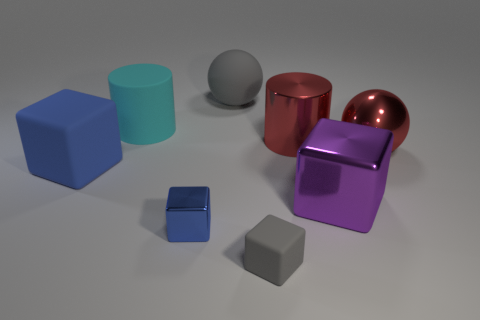There is a big red thing that is the same shape as the large cyan object; what material is it?
Make the answer very short. Metal. There is a metallic object that is to the right of the purple metallic thing; is its shape the same as the big gray rubber thing?
Offer a very short reply. Yes. What size is the sphere that is made of the same material as the purple object?
Your answer should be very brief. Large. The small gray object has what shape?
Your response must be concise. Cube. Is the big purple cube made of the same material as the gray thing that is behind the blue rubber cube?
Your response must be concise. No. What number of things are blue objects or big matte cylinders?
Offer a terse response. 3. Are there any green metallic balls?
Your answer should be compact. No. There is a gray matte thing that is in front of the large ball that is to the left of the big purple block; what is its shape?
Provide a succinct answer. Cube. What number of things are either shiny objects that are behind the large blue object or metallic cubes on the left side of the large shiny cube?
Provide a short and direct response. 3. There is a gray sphere that is the same size as the rubber cylinder; what is it made of?
Make the answer very short. Rubber. 